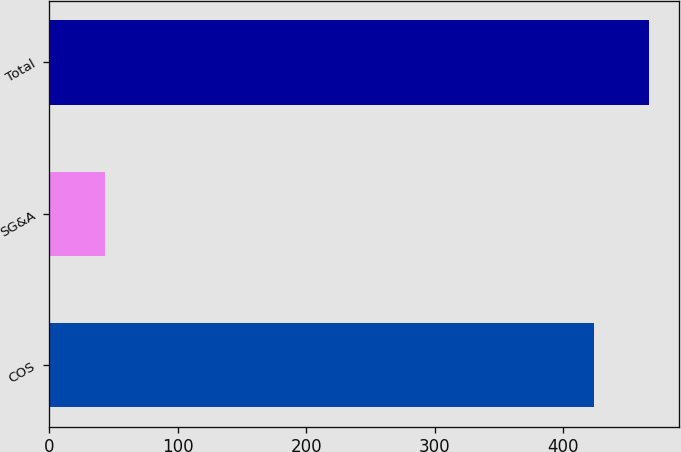<chart> <loc_0><loc_0><loc_500><loc_500><bar_chart><fcel>COS<fcel>SG&A<fcel>Total<nl><fcel>424<fcel>43<fcel>467<nl></chart> 